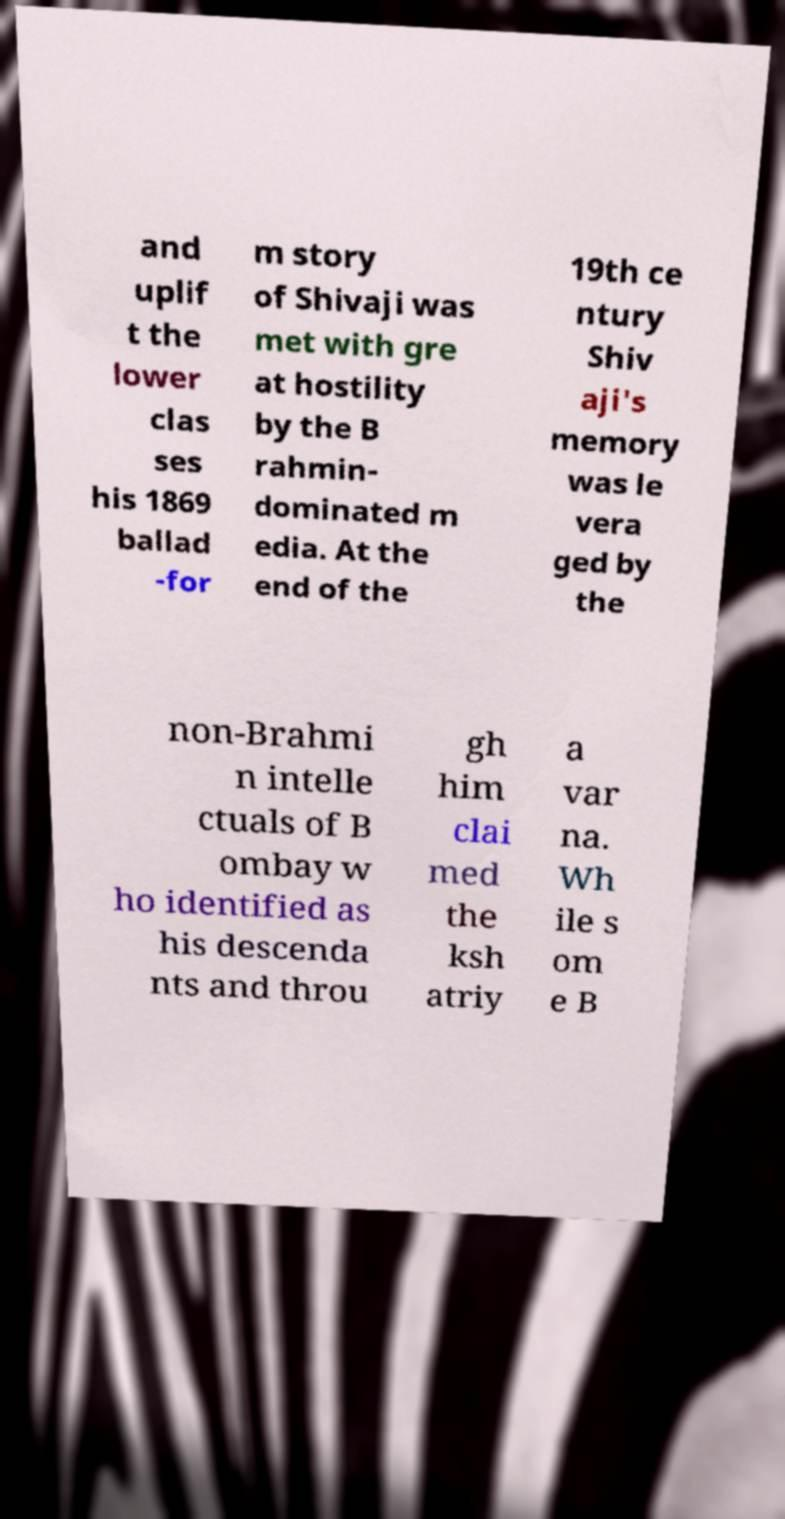Please identify and transcribe the text found in this image. and uplif t the lower clas ses his 1869 ballad -for m story of Shivaji was met with gre at hostility by the B rahmin- dominated m edia. At the end of the 19th ce ntury Shiv aji's memory was le vera ged by the non-Brahmi n intelle ctuals of B ombay w ho identified as his descenda nts and throu gh him clai med the ksh atriy a var na. Wh ile s om e B 